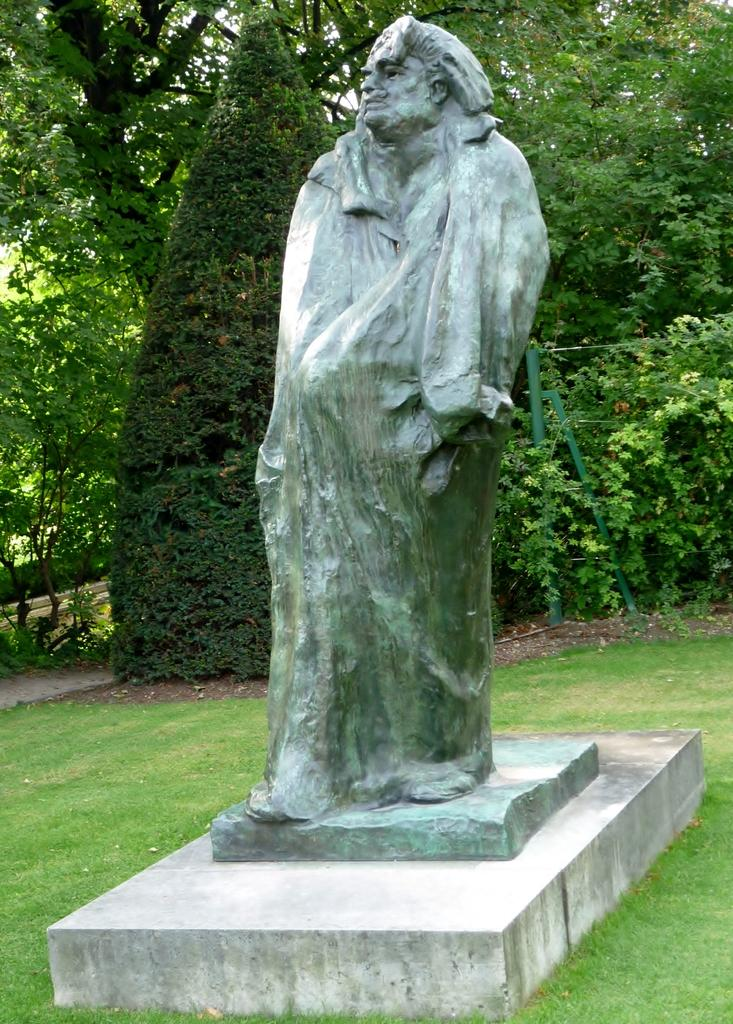What is there is a statue in the middle of the image, what is it made of? The facts provided do not mention the material of the statue. What can be seen in the background of the image? There are trees in the background of the image. What is the ground made of in the image? The ground is covered with grass in the image. Is there a door visible in the image? No, there is no door present in the image. 